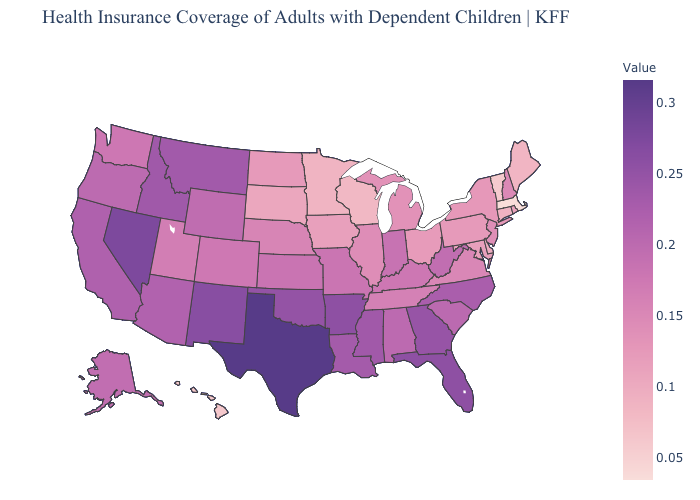Which states have the highest value in the USA?
Keep it brief. Texas. Is the legend a continuous bar?
Quick response, please. Yes. Is the legend a continuous bar?
Short answer required. Yes. Among the states that border New Hampshire , does Massachusetts have the highest value?
Short answer required. No. Which states have the lowest value in the West?
Concise answer only. Hawaii. Among the states that border Louisiana , which have the lowest value?
Keep it brief. Mississippi. Does the map have missing data?
Be succinct. No. 